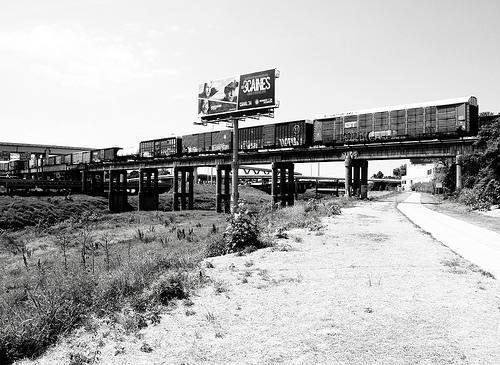How many supports are under the bridge?
Give a very brief answer. 6. 